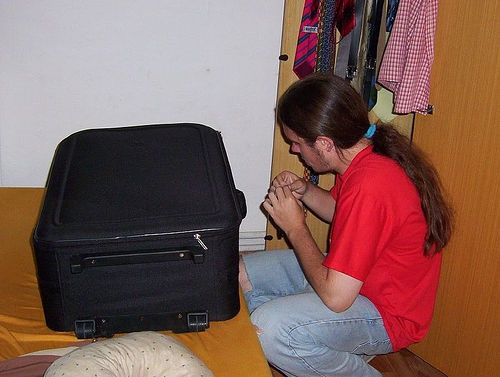Describe the objects in this image and their specific colors. I can see people in darkgray, brown, and black tones, suitcase in darkgray, black, and gray tones, bed in darkgray, brown, maroon, and tan tones, tie in darkgray, black, maroon, and brown tones, and tie in darkgray, black, navy, and gray tones in this image. 